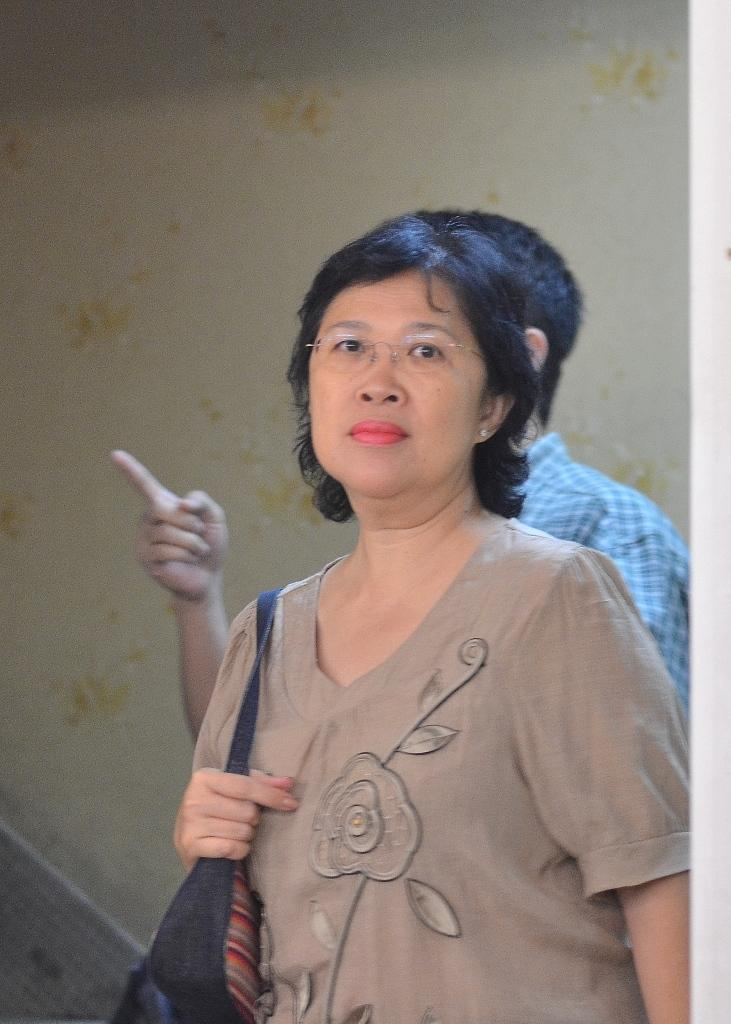Who is the main subject in the image? There is a lady in the image. What is the lady wearing in the image? The lady is wearing specs in the image. What is the lady holding in the image? The lady is holding a bag in the image. Can you describe the background of the image? There is another person and a wall in the background of the image. How many sisters does the lady have in the image? There is no information about the lady's sisters in the image. What is the fifth person doing in the background of the image? There is no mention of a fifth person in the image; only one other person is mentioned in the background. 